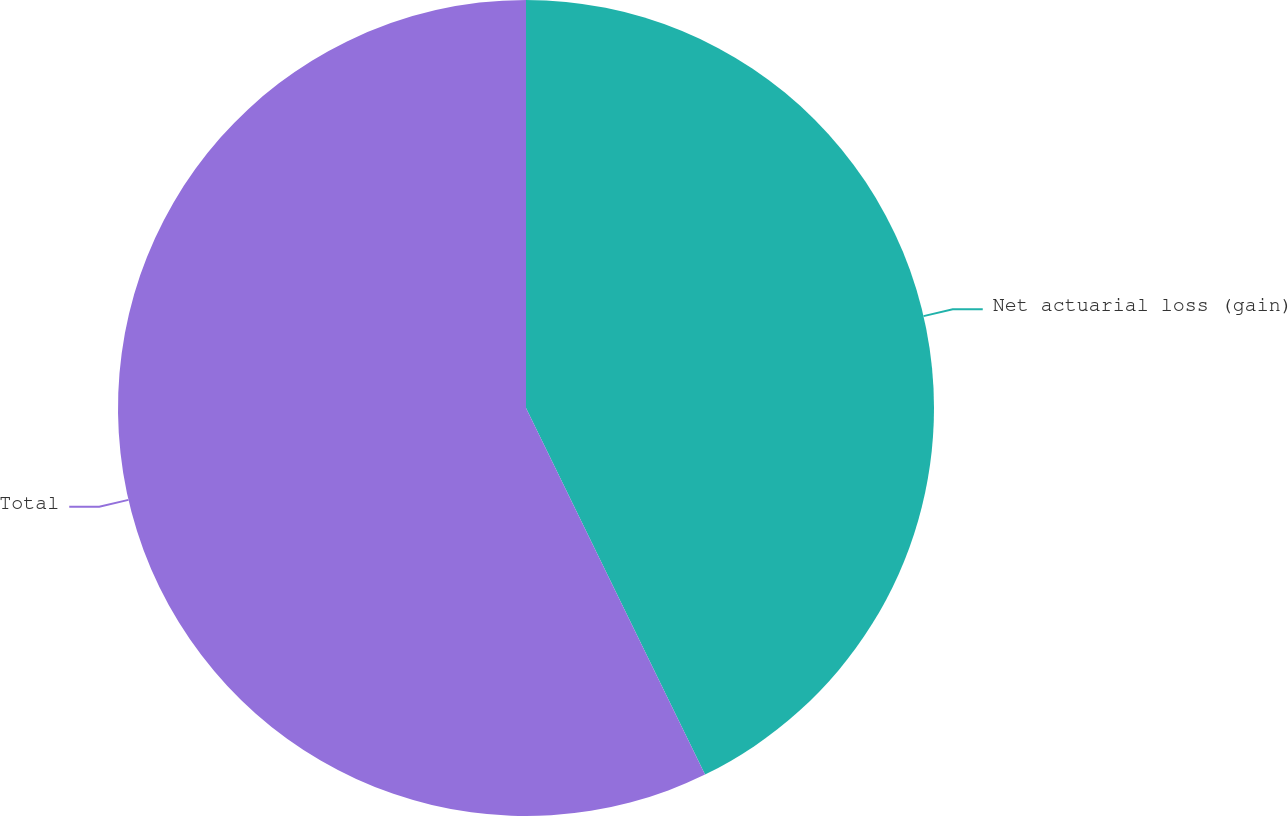Convert chart to OTSL. <chart><loc_0><loc_0><loc_500><loc_500><pie_chart><fcel>Net actuarial loss (gain)<fcel>Total<nl><fcel>42.77%<fcel>57.23%<nl></chart> 